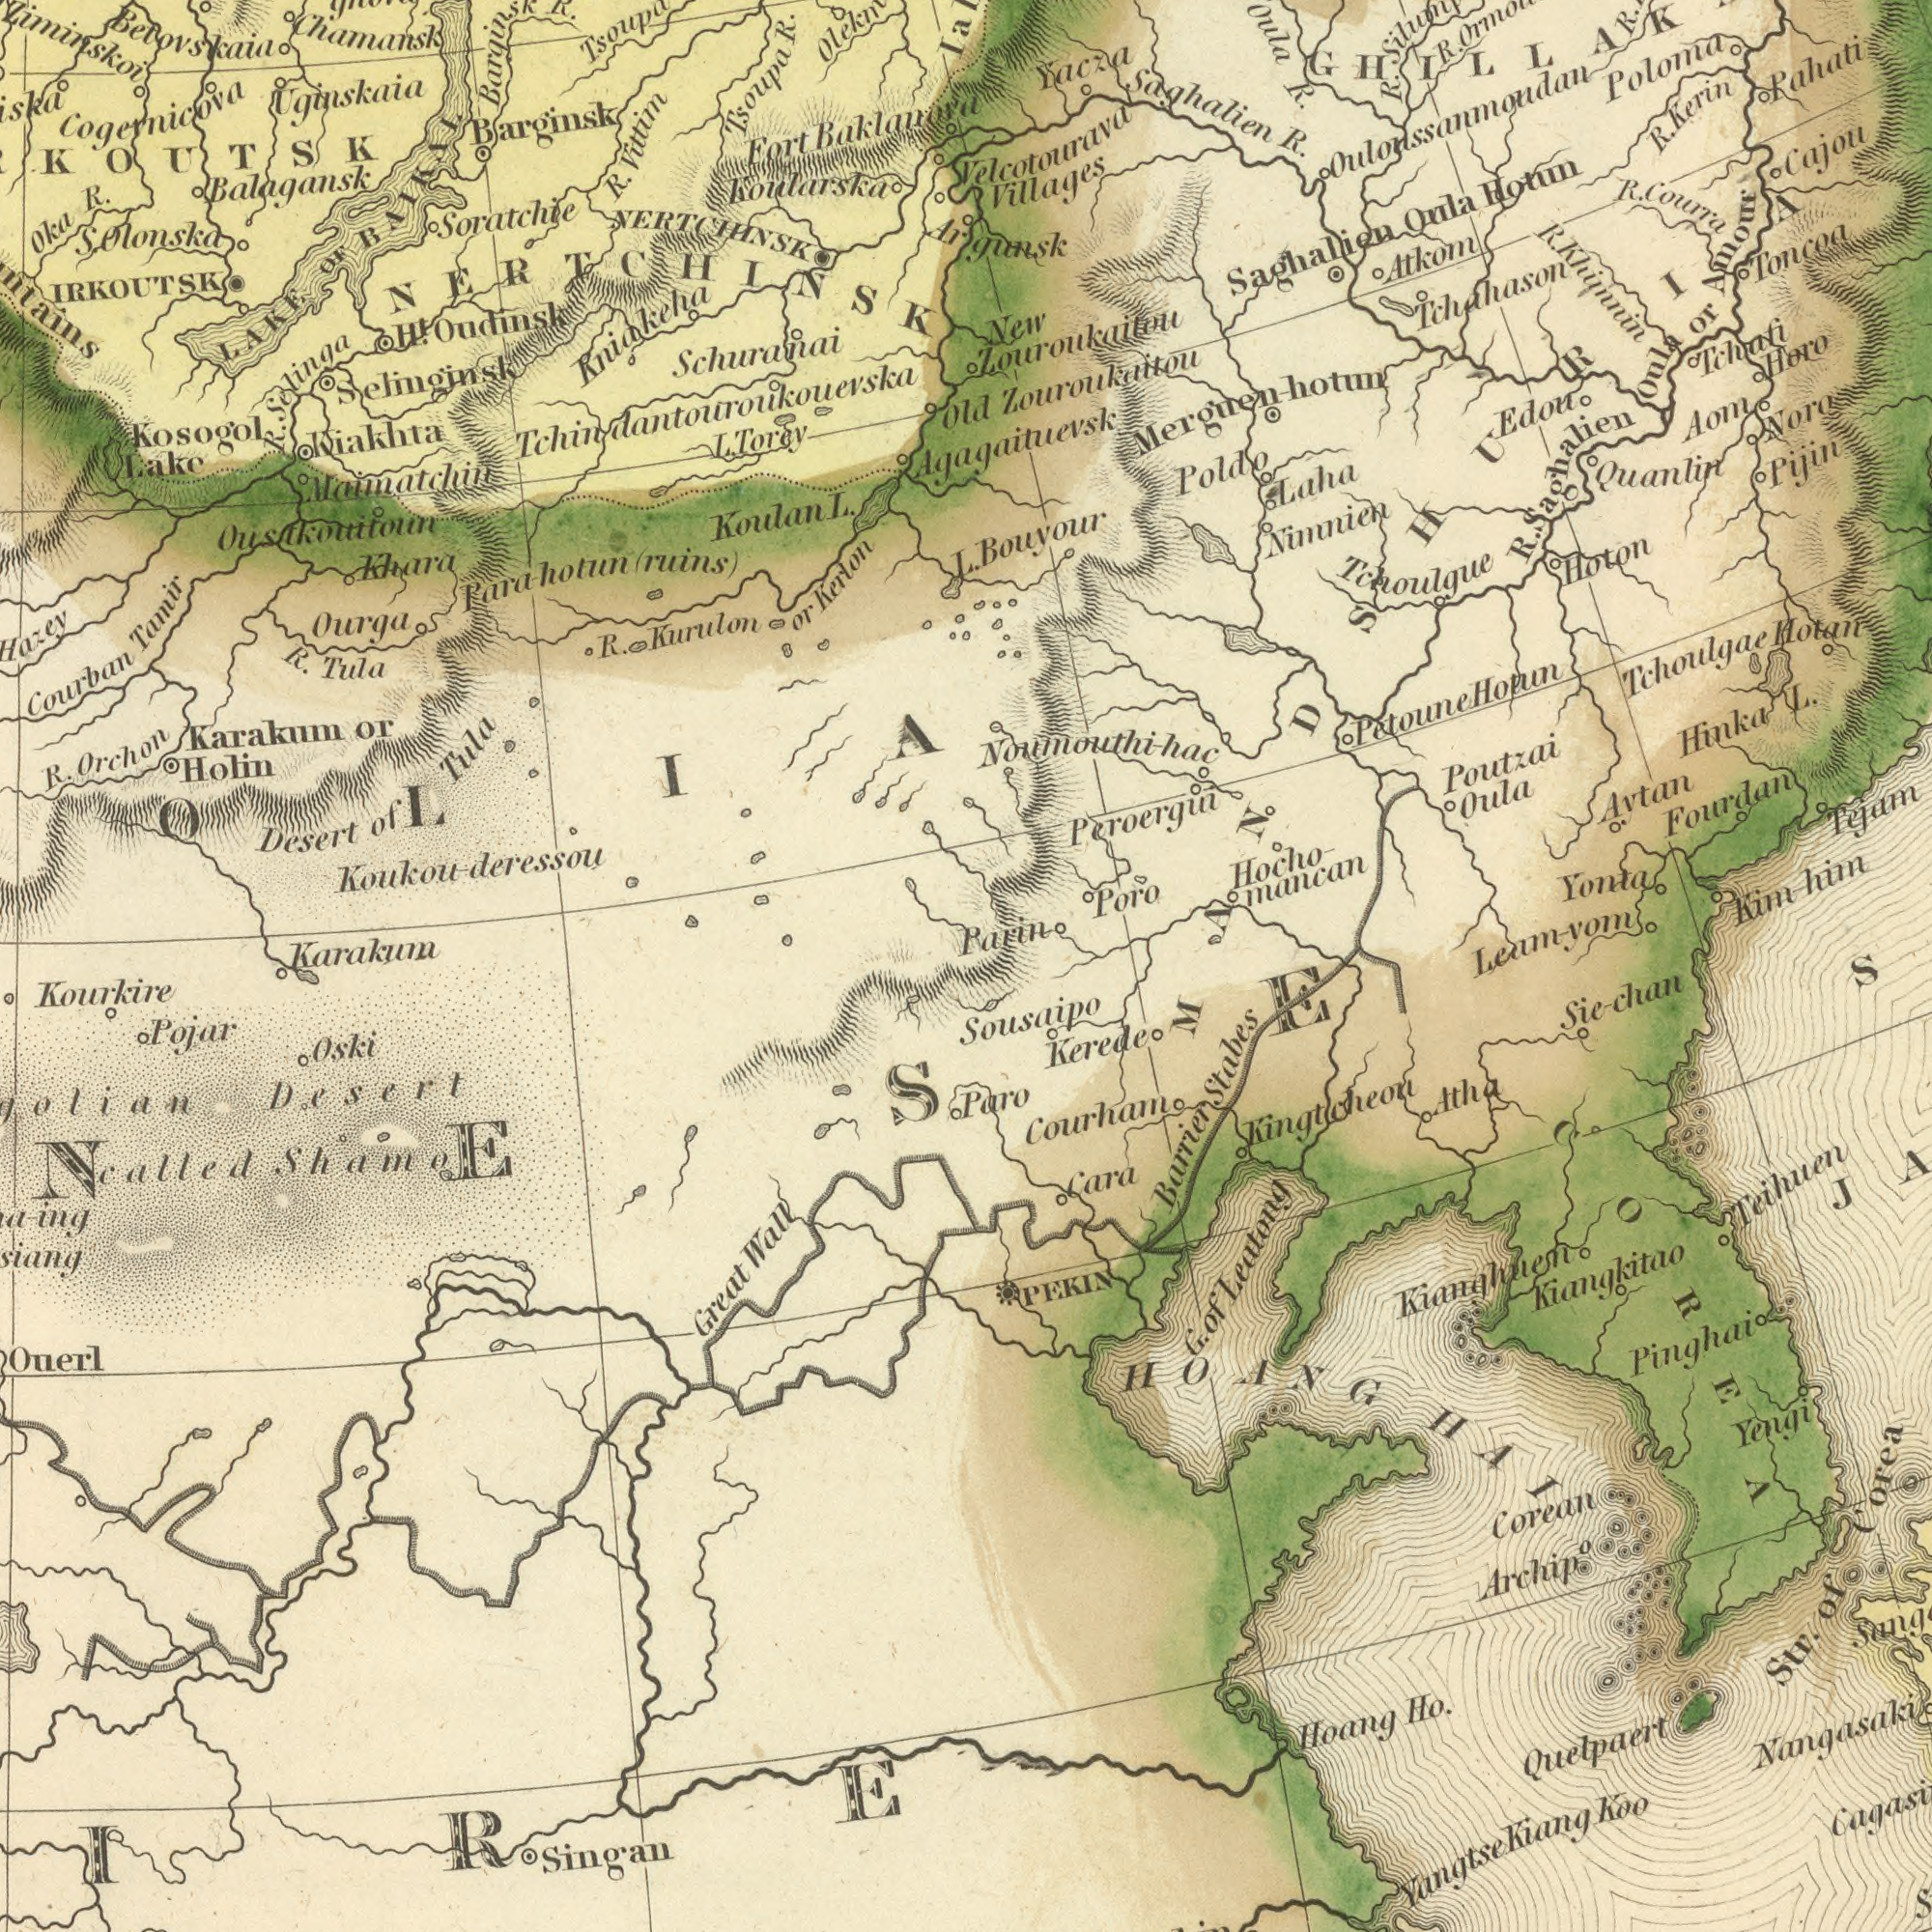What text appears in the bottom-left area of the image? Desert Kourkire Ouerl Pojar Singan Oski Great Wall called Shamo What text is visible in the upper-left corner? Schuranai R. Uginskaia Kosogol Kniakeha LAKE Karakum Maimatchin Barginsk Koukou-deressou Desert Soratchie Koulan R. Kurulon Fort R. Koularska Tamir Para-houtun Tsoupa Courban R. Ourga Holin Tula Oustkouitoun R. Oka Kiakhta Kerlon or Khara Lake Vittim Selinginsk Betovskaia OF Chamansk NERTCHINSK Orchon or Cogernicova R. Karakum R. of Tula Oudinsk (ruins) BAIKAL NERTCHINSK Ziminskoi Balagansk IRKOUTSK S. Olonska Barginsk R. Baklanora Selinga H<sup>t</sup>. Tchindantouroukouevska L. Torey L. ###OLIA What text appears in the bottom-right area of the image? Corea Courham Quelpaert Sousaipo Yangtse Kerede Teihuen Corean Nangasaki Kiang Pinghai Paro Yengi Archip<sup>o</sup> Koo Kiangkitao Cara Kianghuen Kingtcheon Hoang Leatong of Stabes Atha Str. Barrier PEKIN HOANGHAI Sie-chan G. of COREA Ho. What text can you see in the top-right section? Argunsk R. Tchoulgue Bouyour Peroergui Saghalien Yacza Tchoulgae Kim-him Nimnien Poutzai Villages Toncoa Leam-yom Atkom L. R. Tchahason Oula Poloma Hoton Khimnin New Hocho- Quanlin Poldo Yonta Hotun Noro Parin Pahati or Tejam Edou Hinka Fourdan Merguen-hotun Tchati Cajou Pijin Horo Oula Aom Laha Amour Noumouthi-hac Oula Kerin Zouroukaitou mancan Hotan R. Saghalien Avtan Poro R. Old Hotun Velcotourava R. Courra Zouroukaitou Petoune Oulonssanmoudan R. R. R. Agagaituevsk R. MANDSHURIA L. Saghalien 